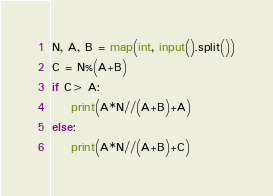Convert code to text. <code><loc_0><loc_0><loc_500><loc_500><_Python_>N, A, B = map(int, input().split())
C = N%(A+B)
if C> A:
    print(A*N//(A+B)+A)
else:
    print(A*N//(A+B)+C)
</code> 